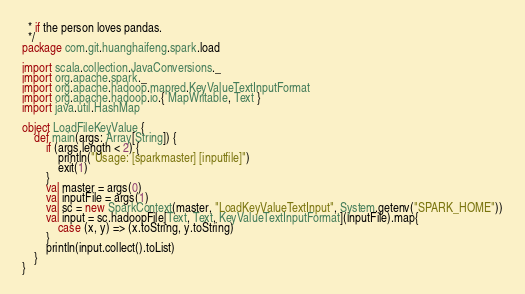Convert code to text. <code><loc_0><loc_0><loc_500><loc_500><_Scala_>  * if the person loves pandas.
  */
package com.git.huanghaifeng.spark.load

import scala.collection.JavaConversions._
import org.apache.spark._
import org.apache.hadoop.mapred.KeyValueTextInputFormat
import org.apache.hadoop.io.{ MapWritable, Text }
import java.util.HashMap

object LoadFileKeyValue {
    def main(args: Array[String]) {
        if (args.length < 2) {
            println("Usage: [sparkmaster] [inputfile]")
            exit(1)
        }
        val master = args(0)
        val inputFile = args(1)
        val sc = new SparkContext(master, "LoadKeyValueTextInput", System.getenv("SPARK_HOME"))
        val input = sc.hadoopFile[Text, Text, KeyValueTextInputFormat](inputFile).map{
            case (x, y) => (x.toString, y.toString)
        }
        println(input.collect().toList)
    }
}
</code> 